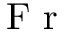Convert formula to latex. <formula><loc_0><loc_0><loc_500><loc_500>F r</formula> 